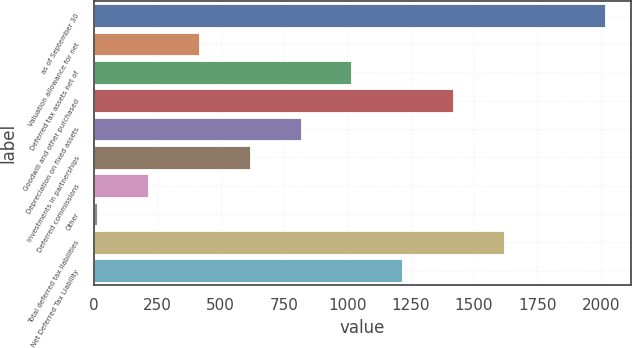Convert chart to OTSL. <chart><loc_0><loc_0><loc_500><loc_500><bar_chart><fcel>as of September 30<fcel>Valuation allowance for net<fcel>Deferred tax assets net of<fcel>Goodwill and other purchased<fcel>Depreciation on fixed assets<fcel>Investments in partnerships<fcel>Deferred commissions<fcel>Other<fcel>Total deferred tax liabilities<fcel>Net Deferred Tax Liability<nl><fcel>2017<fcel>415.08<fcel>1015.8<fcel>1416.28<fcel>815.56<fcel>615.32<fcel>214.84<fcel>14.6<fcel>1616.52<fcel>1216.04<nl></chart> 